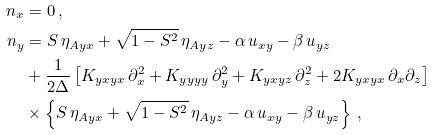Convert formula to latex. <formula><loc_0><loc_0><loc_500><loc_500>n _ { x } & = 0 \, , \\ n _ { y } & = S \, \eta _ { A y x } + \sqrt { 1 - S ^ { 2 } } \, \eta _ { A y z } - \alpha \, u _ { x y } - \beta \, u _ { y z } \\ & + \frac { 1 } { 2 \Delta } \left [ K _ { y x y x } \, \partial _ { x } ^ { 2 } + K _ { y y y y } \, \partial _ { y } ^ { 2 } + K _ { y x y z } \, \partial _ { z } ^ { 2 } + 2 K _ { y x y x } \, \partial _ { x } \partial _ { z } \right ] \\ & \times \left \{ S \, \eta _ { A y x } + \sqrt { 1 - S ^ { 2 } } \, \eta _ { A y z } - \alpha \, u _ { x y } - \beta \, u _ { y z } \right \} \, ,</formula> 